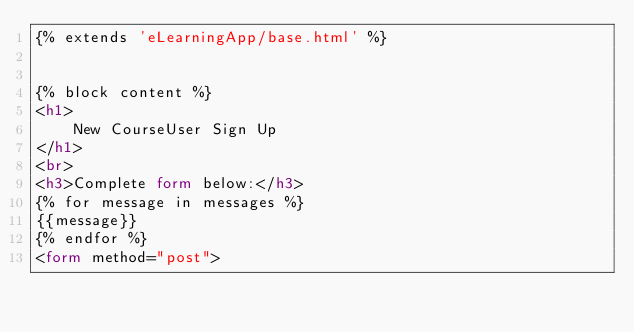<code> <loc_0><loc_0><loc_500><loc_500><_HTML_>{% extends 'eLearningApp/base.html' %}


{% block content %}
<h1>
    New CourseUser Sign Up
</h1>
<br>
<h3>Complete form below:</h3>
{% for message in messages %}
{{message}}
{% endfor %}
<form method="post"></code> 